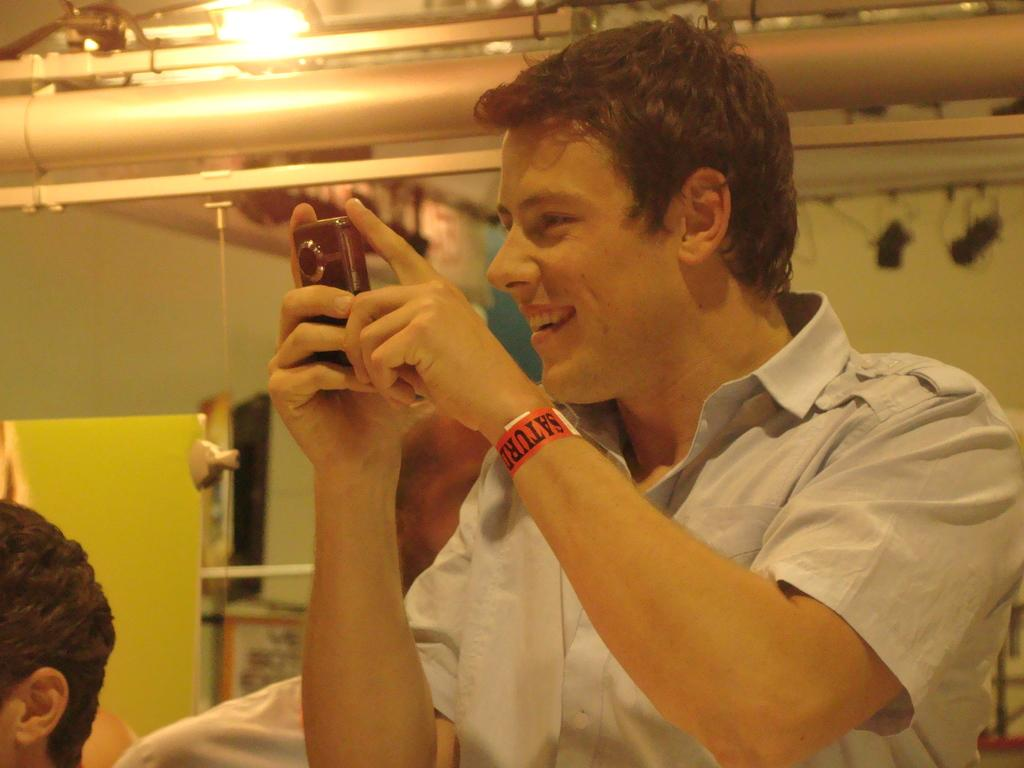What is the main subject of the image? The main subject of the image is a man. What is the man doing in the image? The man is standing and smiling in the image. What is the man holding in his hands? The man is holding a camera in his hands. What is the man wearing in the image? The man is wearing a shirt in the image. What can be observed about the lighting in the image? There is light in the image. How many friends is the man talking to in the image? There is no indication of friends in the image; it only shows a man holding a camera and smiling. What type of crush is the man looking at in the image? There is no mention of a crush in the image; it only shows a man holding a camera and smiling. 